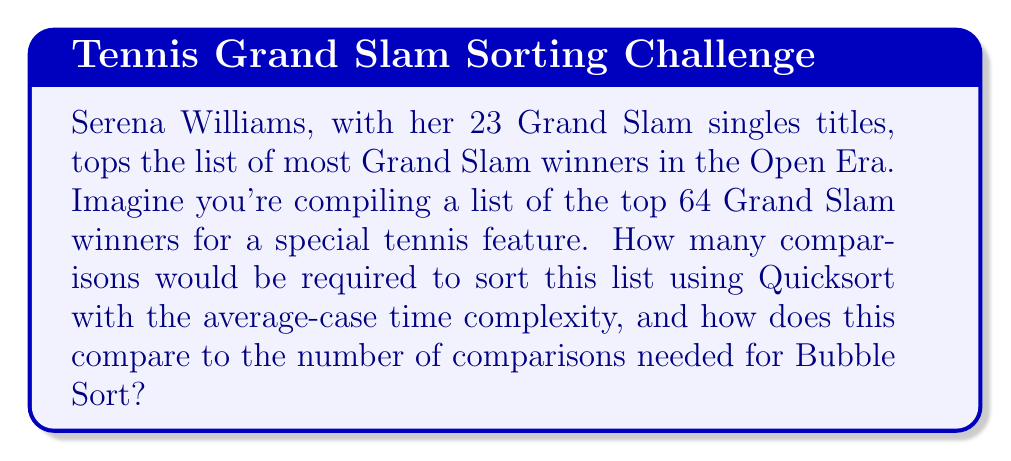Help me with this question. To solve this problem, let's break it down step by step:

1. We have $n = 64$ Grand Slam winners to sort.

2. For Quicksort:
   - The average-case time complexity of Quicksort is $O(n \log n)$.
   - The average number of comparisons for Quicksort is approximately $1.39n \log_2 n$.
   - Substituting $n = 64$:
     $$1.39 \cdot 64 \cdot \log_2 64 = 1.39 \cdot 64 \cdot 6 = 534.24$$
   - Rounding to the nearest whole number: 534 comparisons.

3. For Bubble Sort:
   - Bubble Sort always performs $\frac{n(n-1)}{2}$ comparisons.
   - Substituting $n = 64$:
     $$\frac{64(64-1)}{2} = \frac{64 \cdot 63}{2} = 2016$$

4. Comparison:
   - Quicksort (average case): 534 comparisons
   - Bubble Sort: 2016 comparisons
   - Difference: $2016 - 534 = 1482$ comparisons

5. Percentage difference:
   $$\frac{2016 - 534}{2016} \cdot 100\% \approx 73.5\%$$

Quicksort performs approximately 73.5% fewer comparisons than Bubble Sort for this list size.
Answer: Quicksort would require approximately 534 comparisons on average to sort the list of 64 Grand Slam winners, while Bubble Sort would require 2016 comparisons. Quicksort performs about 73.5% fewer comparisons than Bubble Sort for this task. 